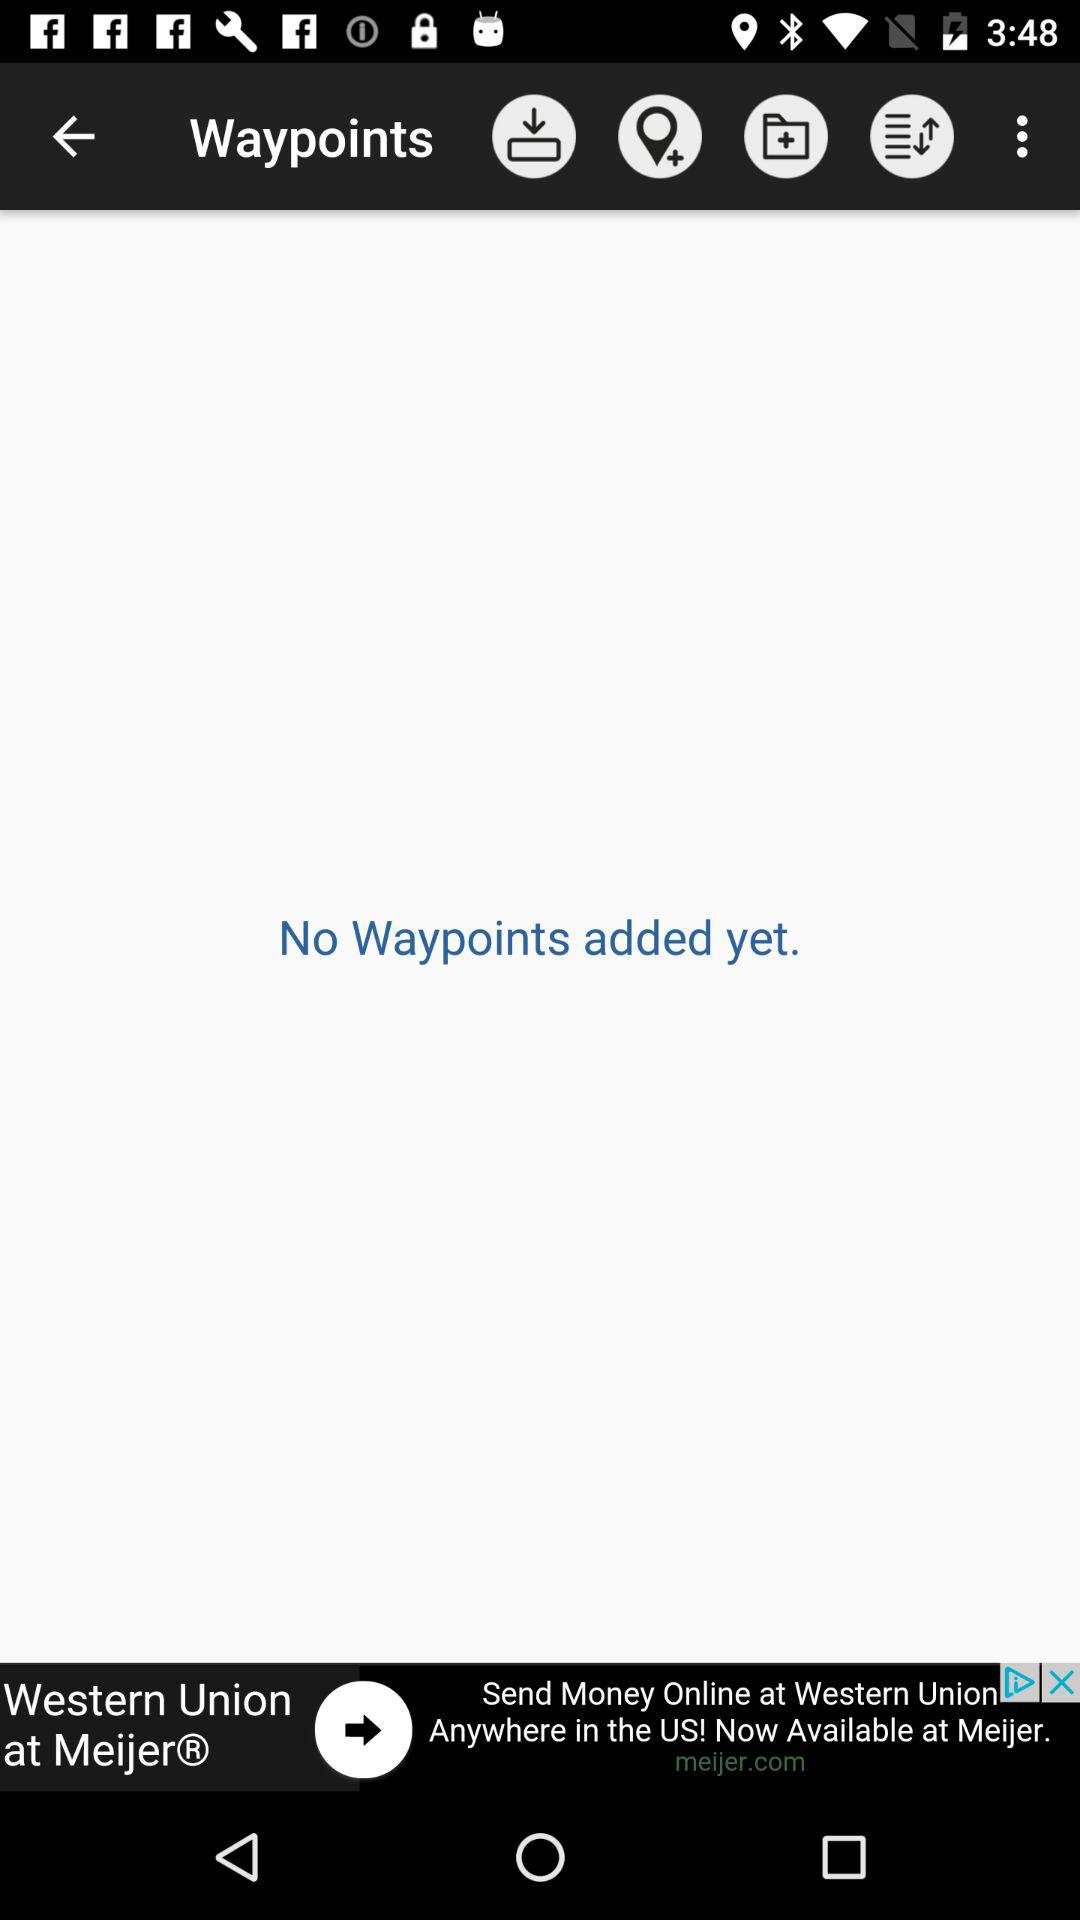How can we contact Western Union by phone?
When the provided information is insufficient, respond with <no answer>. <no answer> 